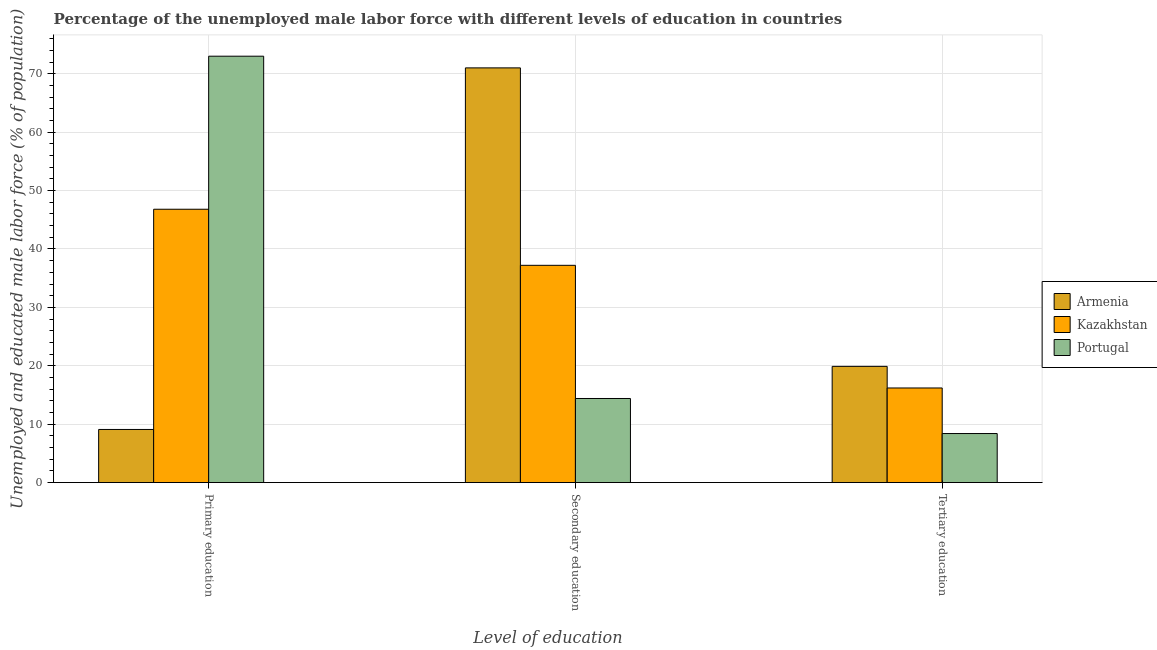How many groups of bars are there?
Your answer should be compact. 3. Are the number of bars on each tick of the X-axis equal?
Offer a very short reply. Yes. How many bars are there on the 2nd tick from the left?
Your answer should be very brief. 3. What is the label of the 3rd group of bars from the left?
Your answer should be compact. Tertiary education. What is the percentage of male labor force who received secondary education in Armenia?
Make the answer very short. 71. Across all countries, what is the maximum percentage of male labor force who received primary education?
Provide a succinct answer. 73. Across all countries, what is the minimum percentage of male labor force who received secondary education?
Provide a short and direct response. 14.4. What is the total percentage of male labor force who received secondary education in the graph?
Offer a terse response. 122.6. What is the difference between the percentage of male labor force who received secondary education in Armenia and that in Portugal?
Your answer should be very brief. 56.6. What is the difference between the percentage of male labor force who received tertiary education in Kazakhstan and the percentage of male labor force who received primary education in Portugal?
Your response must be concise. -56.8. What is the average percentage of male labor force who received tertiary education per country?
Offer a very short reply. 14.83. What is the difference between the percentage of male labor force who received tertiary education and percentage of male labor force who received secondary education in Armenia?
Give a very brief answer. -51.1. In how many countries, is the percentage of male labor force who received primary education greater than 58 %?
Make the answer very short. 1. What is the ratio of the percentage of male labor force who received primary education in Armenia to that in Kazakhstan?
Ensure brevity in your answer.  0.19. Is the percentage of male labor force who received tertiary education in Portugal less than that in Kazakhstan?
Provide a short and direct response. Yes. What is the difference between the highest and the second highest percentage of male labor force who received tertiary education?
Make the answer very short. 3.7. What is the difference between the highest and the lowest percentage of male labor force who received primary education?
Make the answer very short. 63.9. Is the sum of the percentage of male labor force who received secondary education in Armenia and Portugal greater than the maximum percentage of male labor force who received primary education across all countries?
Your answer should be very brief. Yes. What does the 1st bar from the left in Secondary education represents?
Your response must be concise. Armenia. What does the 2nd bar from the right in Tertiary education represents?
Your answer should be very brief. Kazakhstan. Are all the bars in the graph horizontal?
Keep it short and to the point. No. Does the graph contain grids?
Your response must be concise. Yes. How many legend labels are there?
Give a very brief answer. 3. What is the title of the graph?
Offer a terse response. Percentage of the unemployed male labor force with different levels of education in countries. Does "Comoros" appear as one of the legend labels in the graph?
Provide a short and direct response. No. What is the label or title of the X-axis?
Provide a succinct answer. Level of education. What is the label or title of the Y-axis?
Give a very brief answer. Unemployed and educated male labor force (% of population). What is the Unemployed and educated male labor force (% of population) of Armenia in Primary education?
Give a very brief answer. 9.1. What is the Unemployed and educated male labor force (% of population) of Kazakhstan in Primary education?
Offer a very short reply. 46.8. What is the Unemployed and educated male labor force (% of population) in Portugal in Primary education?
Your answer should be very brief. 73. What is the Unemployed and educated male labor force (% of population) in Kazakhstan in Secondary education?
Your answer should be very brief. 37.2. What is the Unemployed and educated male labor force (% of population) of Portugal in Secondary education?
Offer a terse response. 14.4. What is the Unemployed and educated male labor force (% of population) in Armenia in Tertiary education?
Your response must be concise. 19.9. What is the Unemployed and educated male labor force (% of population) of Kazakhstan in Tertiary education?
Provide a succinct answer. 16.2. What is the Unemployed and educated male labor force (% of population) in Portugal in Tertiary education?
Make the answer very short. 8.4. Across all Level of education, what is the maximum Unemployed and educated male labor force (% of population) in Kazakhstan?
Keep it short and to the point. 46.8. Across all Level of education, what is the minimum Unemployed and educated male labor force (% of population) of Armenia?
Offer a terse response. 9.1. Across all Level of education, what is the minimum Unemployed and educated male labor force (% of population) in Kazakhstan?
Offer a very short reply. 16.2. Across all Level of education, what is the minimum Unemployed and educated male labor force (% of population) in Portugal?
Keep it short and to the point. 8.4. What is the total Unemployed and educated male labor force (% of population) in Armenia in the graph?
Make the answer very short. 100. What is the total Unemployed and educated male labor force (% of population) of Kazakhstan in the graph?
Keep it short and to the point. 100.2. What is the total Unemployed and educated male labor force (% of population) in Portugal in the graph?
Ensure brevity in your answer.  95.8. What is the difference between the Unemployed and educated male labor force (% of population) of Armenia in Primary education and that in Secondary education?
Provide a succinct answer. -61.9. What is the difference between the Unemployed and educated male labor force (% of population) in Kazakhstan in Primary education and that in Secondary education?
Your response must be concise. 9.6. What is the difference between the Unemployed and educated male labor force (% of population) in Portugal in Primary education and that in Secondary education?
Offer a terse response. 58.6. What is the difference between the Unemployed and educated male labor force (% of population) in Armenia in Primary education and that in Tertiary education?
Provide a succinct answer. -10.8. What is the difference between the Unemployed and educated male labor force (% of population) of Kazakhstan in Primary education and that in Tertiary education?
Make the answer very short. 30.6. What is the difference between the Unemployed and educated male labor force (% of population) in Portugal in Primary education and that in Tertiary education?
Your response must be concise. 64.6. What is the difference between the Unemployed and educated male labor force (% of population) of Armenia in Secondary education and that in Tertiary education?
Keep it short and to the point. 51.1. What is the difference between the Unemployed and educated male labor force (% of population) in Armenia in Primary education and the Unemployed and educated male labor force (% of population) in Kazakhstan in Secondary education?
Provide a short and direct response. -28.1. What is the difference between the Unemployed and educated male labor force (% of population) in Armenia in Primary education and the Unemployed and educated male labor force (% of population) in Portugal in Secondary education?
Offer a terse response. -5.3. What is the difference between the Unemployed and educated male labor force (% of population) of Kazakhstan in Primary education and the Unemployed and educated male labor force (% of population) of Portugal in Secondary education?
Keep it short and to the point. 32.4. What is the difference between the Unemployed and educated male labor force (% of population) of Kazakhstan in Primary education and the Unemployed and educated male labor force (% of population) of Portugal in Tertiary education?
Offer a terse response. 38.4. What is the difference between the Unemployed and educated male labor force (% of population) in Armenia in Secondary education and the Unemployed and educated male labor force (% of population) in Kazakhstan in Tertiary education?
Offer a very short reply. 54.8. What is the difference between the Unemployed and educated male labor force (% of population) of Armenia in Secondary education and the Unemployed and educated male labor force (% of population) of Portugal in Tertiary education?
Make the answer very short. 62.6. What is the difference between the Unemployed and educated male labor force (% of population) in Kazakhstan in Secondary education and the Unemployed and educated male labor force (% of population) in Portugal in Tertiary education?
Offer a terse response. 28.8. What is the average Unemployed and educated male labor force (% of population) of Armenia per Level of education?
Ensure brevity in your answer.  33.33. What is the average Unemployed and educated male labor force (% of population) in Kazakhstan per Level of education?
Offer a terse response. 33.4. What is the average Unemployed and educated male labor force (% of population) of Portugal per Level of education?
Provide a succinct answer. 31.93. What is the difference between the Unemployed and educated male labor force (% of population) of Armenia and Unemployed and educated male labor force (% of population) of Kazakhstan in Primary education?
Provide a succinct answer. -37.7. What is the difference between the Unemployed and educated male labor force (% of population) of Armenia and Unemployed and educated male labor force (% of population) of Portugal in Primary education?
Offer a very short reply. -63.9. What is the difference between the Unemployed and educated male labor force (% of population) of Kazakhstan and Unemployed and educated male labor force (% of population) of Portugal in Primary education?
Ensure brevity in your answer.  -26.2. What is the difference between the Unemployed and educated male labor force (% of population) in Armenia and Unemployed and educated male labor force (% of population) in Kazakhstan in Secondary education?
Your response must be concise. 33.8. What is the difference between the Unemployed and educated male labor force (% of population) of Armenia and Unemployed and educated male labor force (% of population) of Portugal in Secondary education?
Provide a short and direct response. 56.6. What is the difference between the Unemployed and educated male labor force (% of population) in Kazakhstan and Unemployed and educated male labor force (% of population) in Portugal in Secondary education?
Ensure brevity in your answer.  22.8. What is the ratio of the Unemployed and educated male labor force (% of population) in Armenia in Primary education to that in Secondary education?
Your response must be concise. 0.13. What is the ratio of the Unemployed and educated male labor force (% of population) in Kazakhstan in Primary education to that in Secondary education?
Provide a short and direct response. 1.26. What is the ratio of the Unemployed and educated male labor force (% of population) in Portugal in Primary education to that in Secondary education?
Offer a very short reply. 5.07. What is the ratio of the Unemployed and educated male labor force (% of population) in Armenia in Primary education to that in Tertiary education?
Give a very brief answer. 0.46. What is the ratio of the Unemployed and educated male labor force (% of population) of Kazakhstan in Primary education to that in Tertiary education?
Your answer should be very brief. 2.89. What is the ratio of the Unemployed and educated male labor force (% of population) of Portugal in Primary education to that in Tertiary education?
Your answer should be compact. 8.69. What is the ratio of the Unemployed and educated male labor force (% of population) of Armenia in Secondary education to that in Tertiary education?
Make the answer very short. 3.57. What is the ratio of the Unemployed and educated male labor force (% of population) of Kazakhstan in Secondary education to that in Tertiary education?
Your response must be concise. 2.3. What is the ratio of the Unemployed and educated male labor force (% of population) of Portugal in Secondary education to that in Tertiary education?
Your response must be concise. 1.71. What is the difference between the highest and the second highest Unemployed and educated male labor force (% of population) in Armenia?
Give a very brief answer. 51.1. What is the difference between the highest and the second highest Unemployed and educated male labor force (% of population) in Kazakhstan?
Your answer should be very brief. 9.6. What is the difference between the highest and the second highest Unemployed and educated male labor force (% of population) in Portugal?
Provide a succinct answer. 58.6. What is the difference between the highest and the lowest Unemployed and educated male labor force (% of population) of Armenia?
Your answer should be compact. 61.9. What is the difference between the highest and the lowest Unemployed and educated male labor force (% of population) in Kazakhstan?
Provide a short and direct response. 30.6. What is the difference between the highest and the lowest Unemployed and educated male labor force (% of population) in Portugal?
Your answer should be compact. 64.6. 